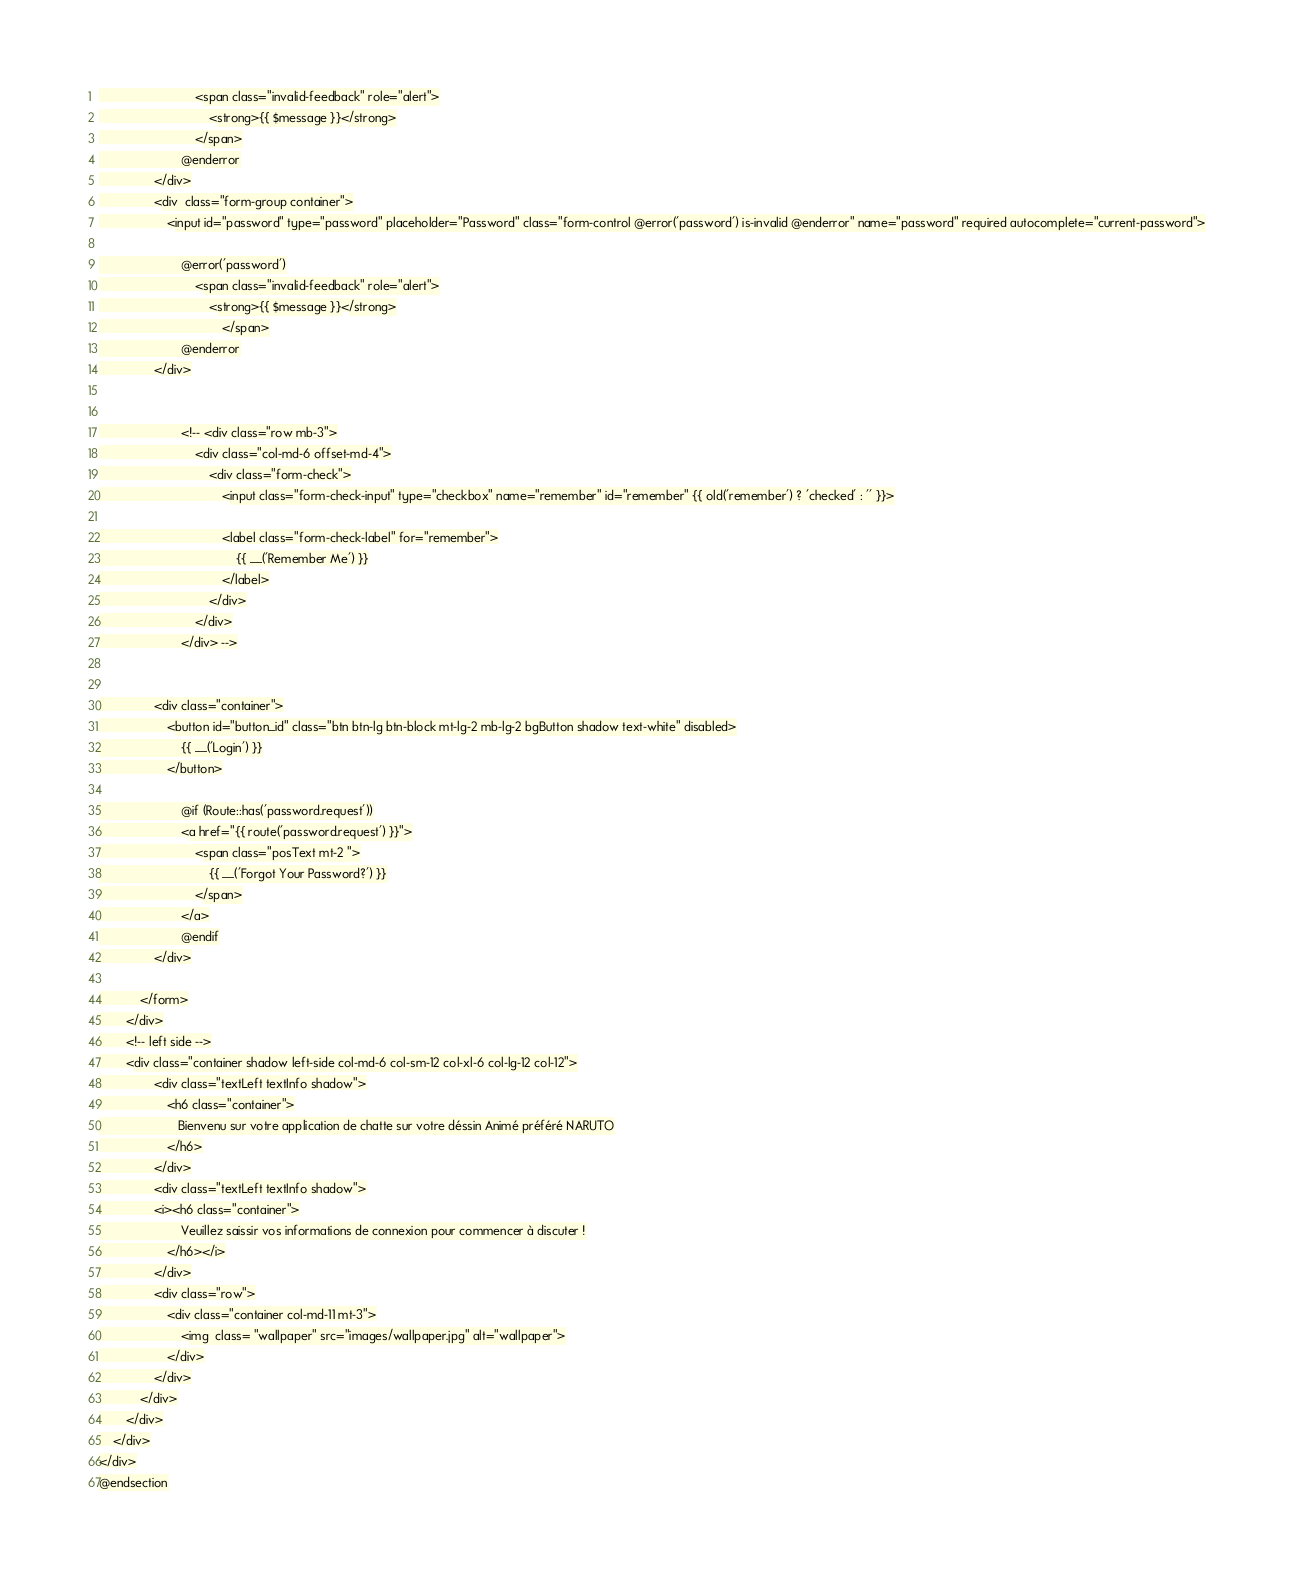<code> <loc_0><loc_0><loc_500><loc_500><_PHP_>                            <span class="invalid-feedback" role="alert">
                                <strong>{{ $message }}</strong>
                            </span>
                        @enderror
                </div>
                <div  class="form-group container">
                    <input id="password" type="password" placeholder="Password" class="form-control @error('password') is-invalid @enderror" name="password" required autocomplete="current-password">

                        @error('password')
                            <span class="invalid-feedback" role="alert">
                                <strong>{{ $message }}</strong>
                                    </span>
                        @enderror
                </div>


                        <!-- <div class="row mb-3">
                            <div class="col-md-6 offset-md-4">
                                <div class="form-check">
                                    <input class="form-check-input" type="checkbox" name="remember" id="remember" {{ old('remember') ? 'checked' : '' }}>

                                    <label class="form-check-label" for="remember">
                                        {{ __('Remember Me') }}
                                    </label>
                                </div>
                            </div>
                        </div> -->


                <div class="container">
                    <button id="button_id" class="btn btn-lg btn-block mt-lg-2 mb-lg-2 bgButton shadow text-white" disabled>
                        {{ __('Login') }}
                    </button>

                        @if (Route::has('password.request'))
                        <a href="{{ route('password.request') }}">
                            <span class="posText mt-2 ">
                                {{ __('Forgot Your Password?') }}
                            </span>
                        </a>
                        @endif
                </div>

            </form>
        </div>
        <!-- left side -->
        <div class="container shadow left-side col-md-6 col-sm-12 col-xl-6 col-lg-12 col-12">
                <div class="textLeft textInfo shadow">
                    <h6 class="container">
                       Bienvenu sur votre application de chatte sur votre déssin Animé préféré NARUTO
                    </h6>
                </div>
                <div class="textLeft textInfo shadow">
                <i><h6 class="container">
                        Veuillez saissir vos informations de connexion pour commencer à discuter !
                    </h6></i>
                </div>
                <div class="row">
                    <div class="container col-md-11 mt-3">
                        <img  class= "wallpaper" src="images/wallpaper.jpg" alt="wallpaper">
                    </div>
                </div>
            </div>
        </div>
    </div>
</div>
@endsection
</code> 